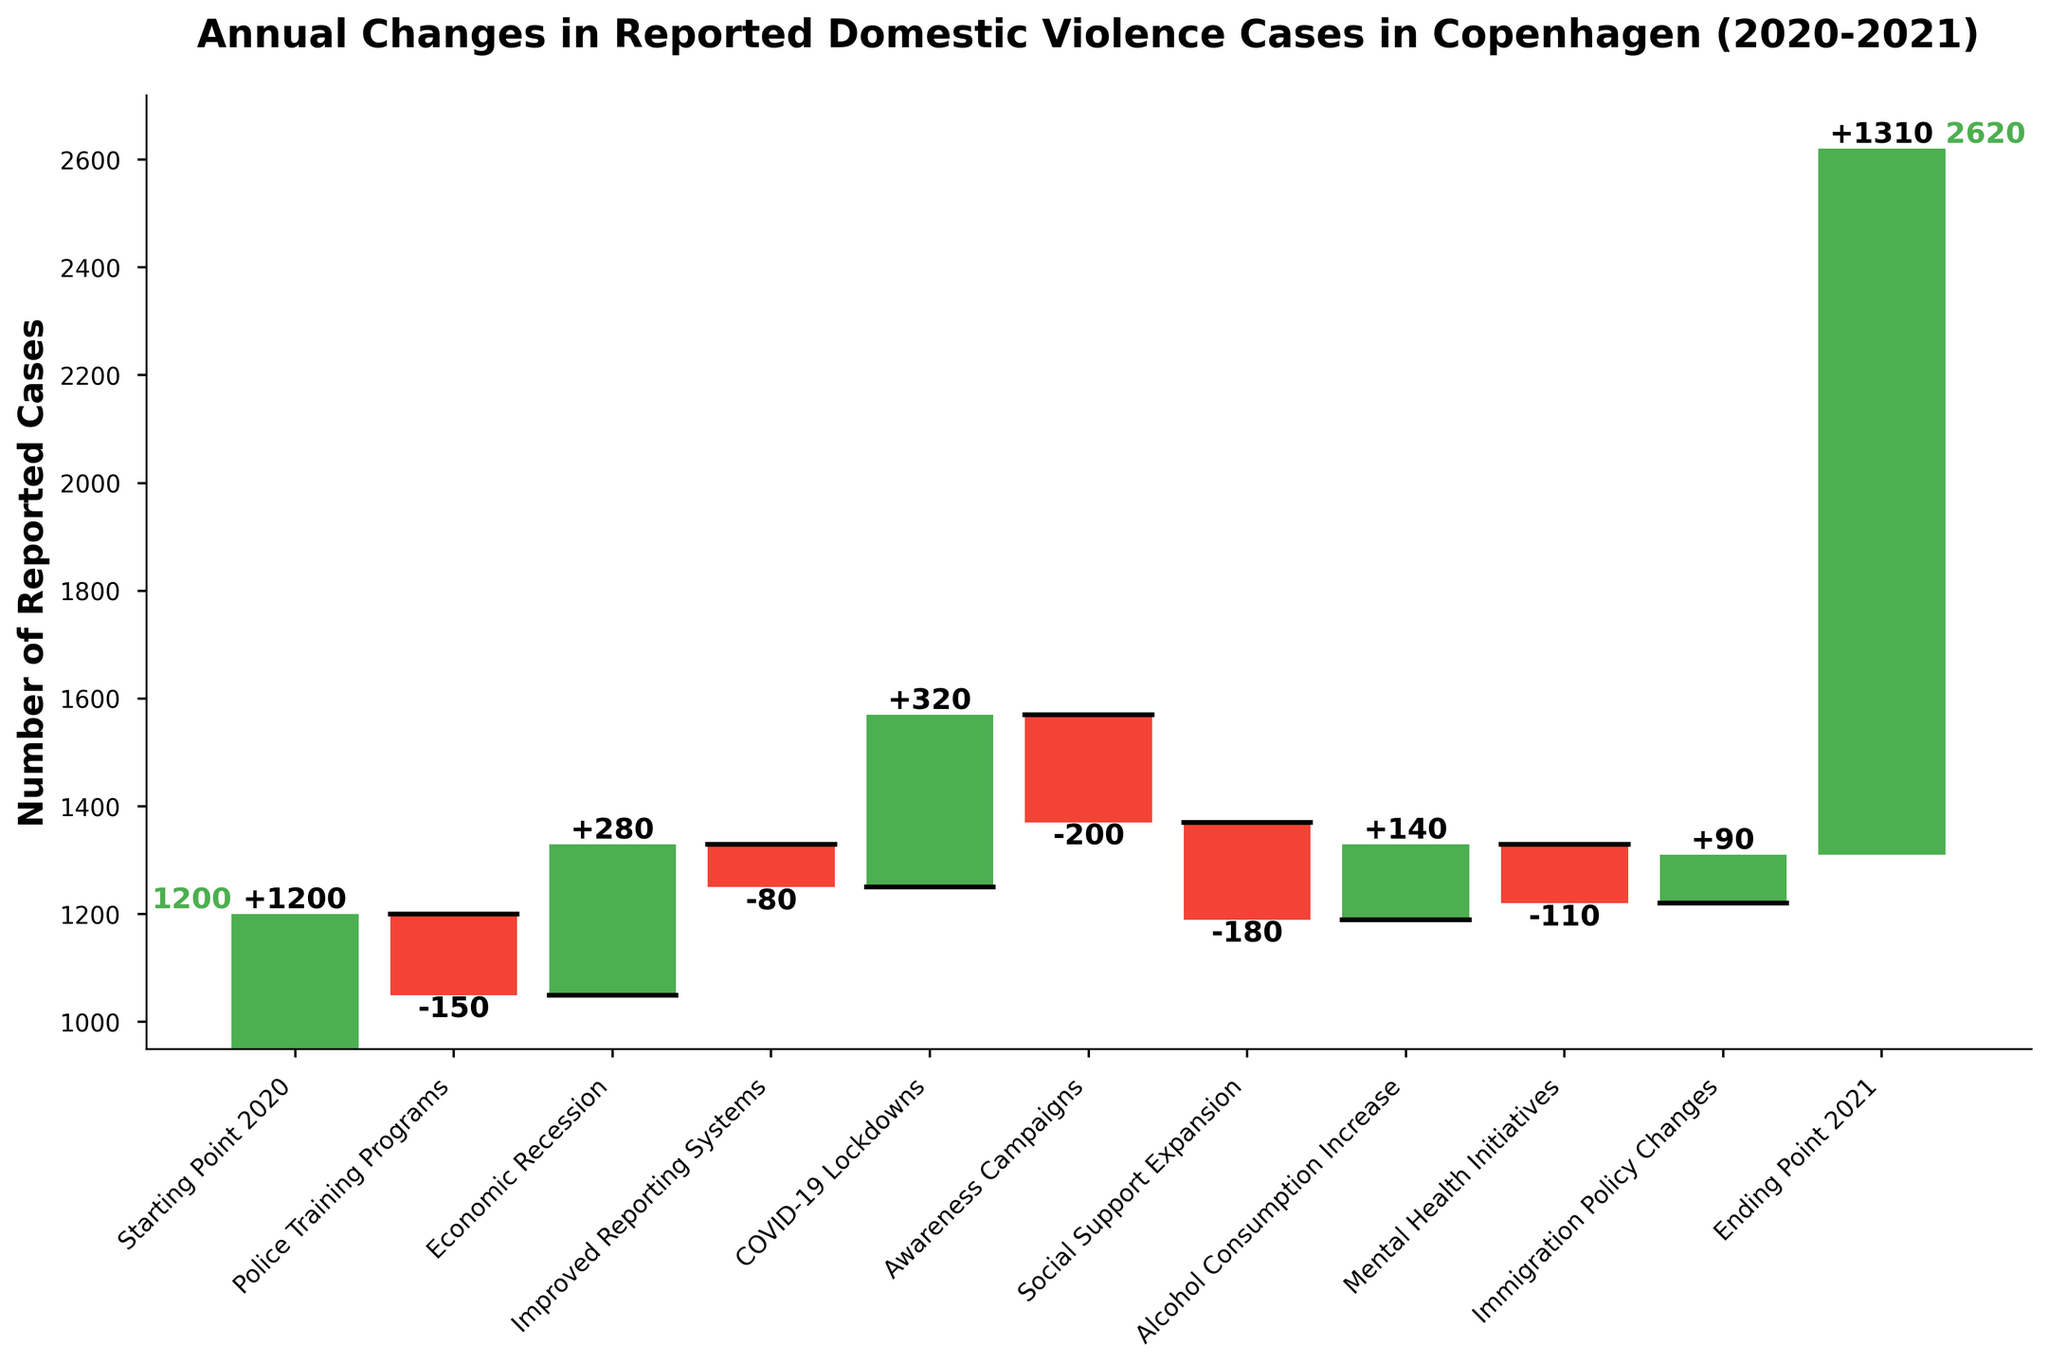What's the starting number of reported domestic violence cases in 2020? The first bar on the left of the chart represents the starting point in 2020, labeled "Starting Point 2020" with a value of 1200 reported cases
Answer: 1200 How many cases were added due to the economic recession? The "Economic Recession" category in the chart indicates a positive (+) value, which signifies an increase of 280 cases
Answer: 280 What is the overall trend shown by the Police Training Programs and Improved Reporting Systems combined? The Police Training Programs show a decrease of 150 cases, and the Improved Reporting Systems show a decrease of 80 cases. Altogether, the reduction is 150 + 80 = 230 cases
Answer: 230 decrease Which factor caused the highest increase in reported cases? From the chart, the COVID-19 Lockdowns category shows the highest increase, represented by a positive value of 320 cases
Answer: COVID-19 Lockdowns How many categories contributed to a decrease in reported cases? By counting the negative values, there are five categories contributing to a decrease: Police Training Programs (-150), Improved Reporting Systems (-80), Awareness Campaigns (-200), Social Support Expansion (-180), and Mental Health Initiatives (-110)
Answer: 5 What is the difference between the increase caused by Alcohol Consumption Increase and the decrease caused by Awareness Campaigns? The increase caused by Alcohol Consumption Increase is +140 cases, and the decrease caused by Awareness Campaigns is -200 cases. The difference is 140 - 200 = -60 cases
Answer: -60 How many more cases were there at the end of 2021 compared to the start of 2020? The chart shows the Ending Point 2021 at 1310 cases, starting from 1200 cases in the Starting Point 2020. The increase is 1310 - 1200 = 110 cases
Answer: 110 Which factor had the smallest impact on reported cases, regardless of increase or decrease? Among all categories, Improved Reporting Systems had the smallest impact, with a decrease of 80 cases
Answer: Improved Reporting Systems How many total cases were added due to factors that caused an increase? Adding the positive values: Economic Recession (280), COVID-19 Lockdowns (320), Alcohol Consumption Increase (140), and Immigration Policy Changes (90), you get 280 + 320 + 140 + 90 = 830 cases
Answer: 830 What is the cumulative effect of the Economic Recession, COVID-19 Lockdowns, and Alcohol Consumption Increase? Summing the values of these factors shows the overall increase: 280 + 320 + 140 = 740 cases
Answer: 740 